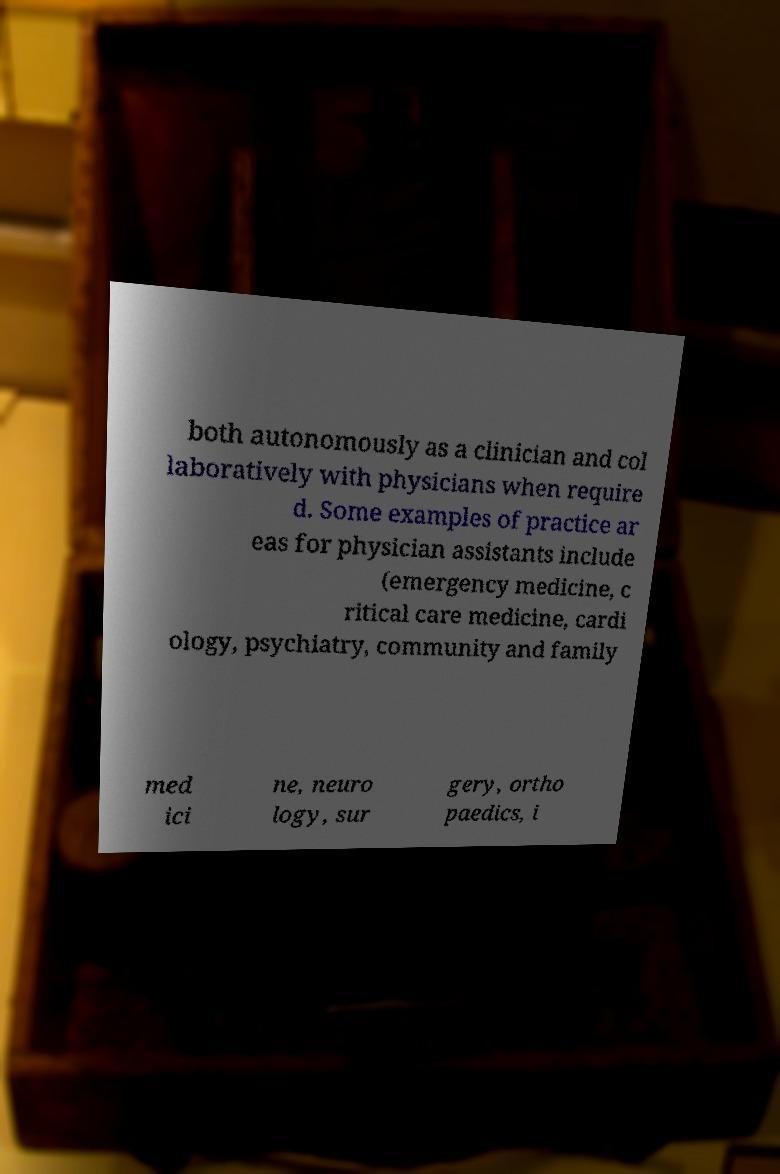Please identify and transcribe the text found in this image. both autonomously as a clinician and col laboratively with physicians when require d. Some examples of practice ar eas for physician assistants include (emergency medicine, c ritical care medicine, cardi ology, psychiatry, community and family med ici ne, neuro logy, sur gery, ortho paedics, i 